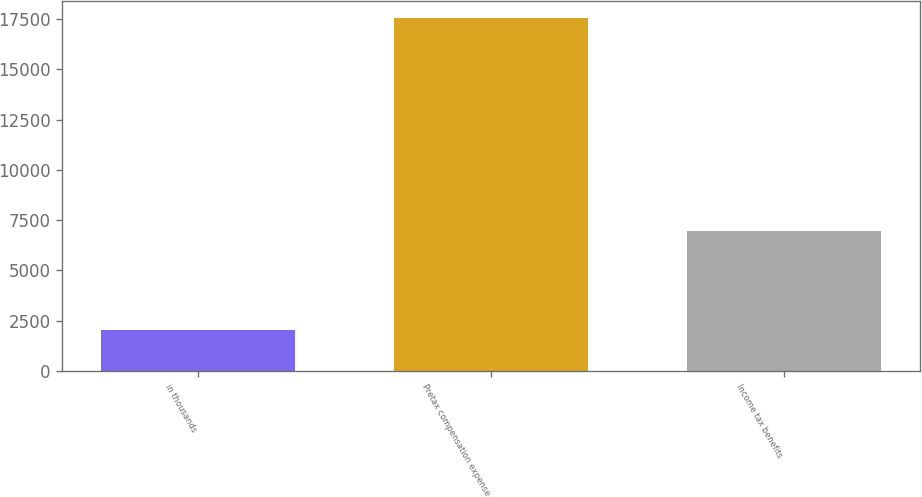Convert chart to OTSL. <chart><loc_0><loc_0><loc_500><loc_500><bar_chart><fcel>in thousands<fcel>Pretax compensation expense<fcel>Income tax benefits<nl><fcel>2011<fcel>17537<fcel>6976<nl></chart> 